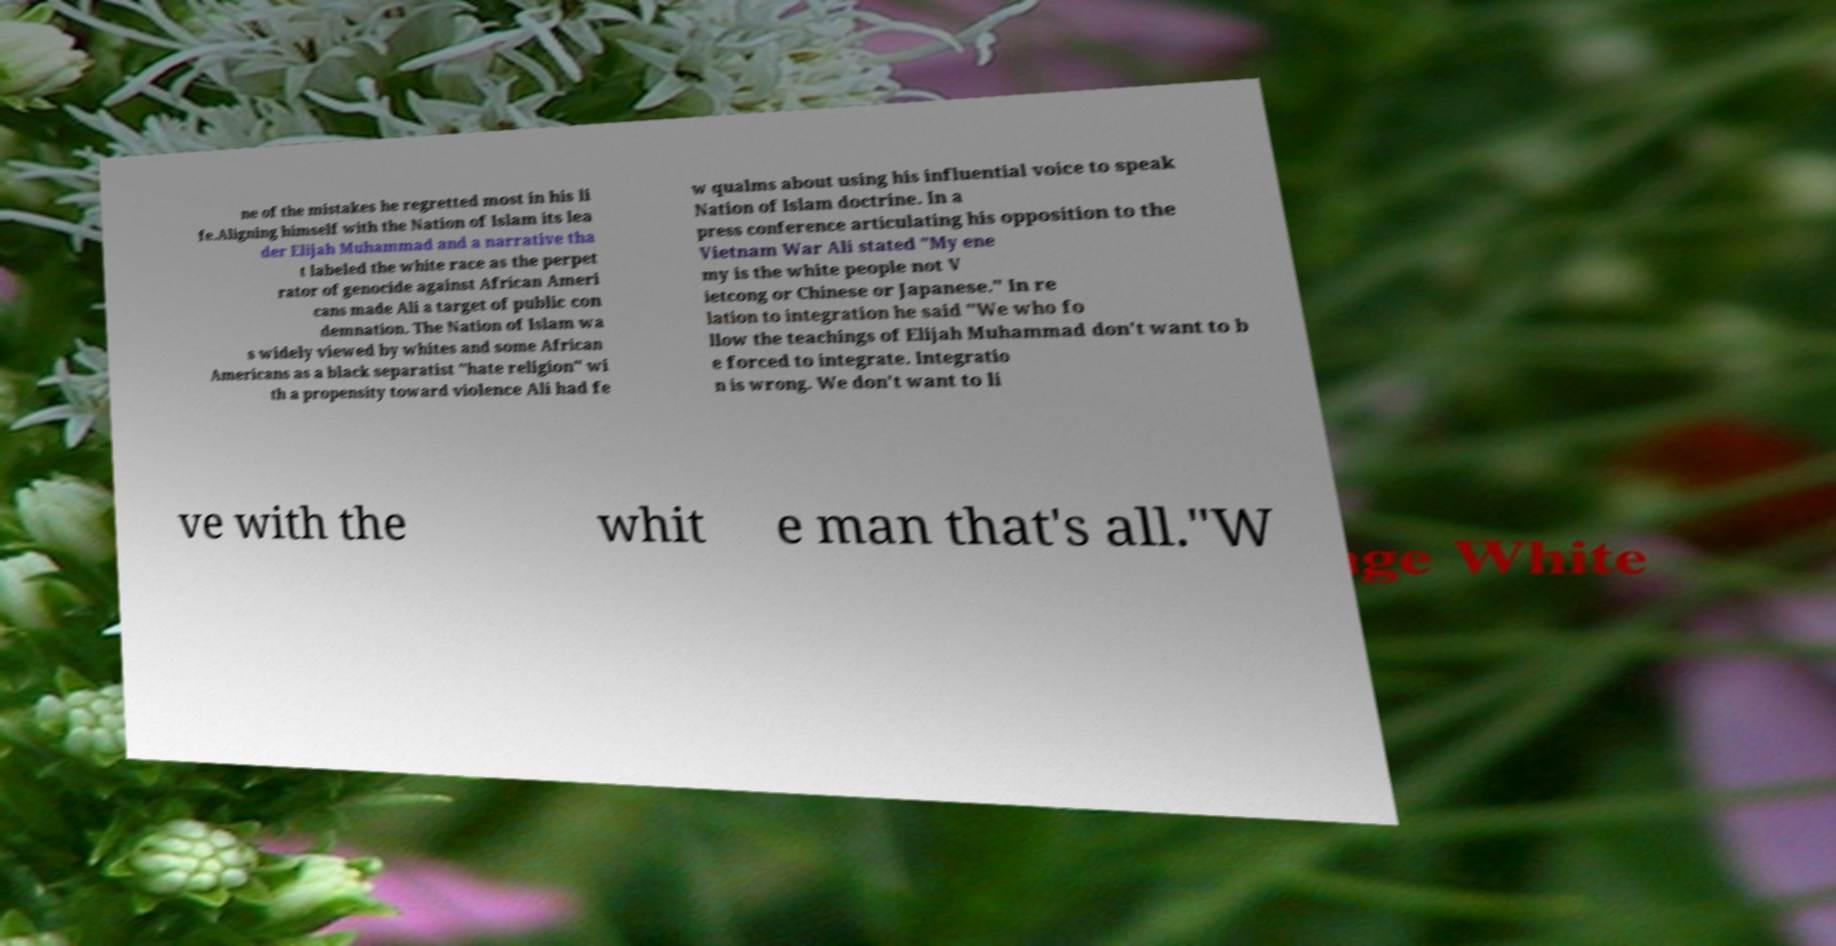Can you accurately transcribe the text from the provided image for me? ne of the mistakes he regretted most in his li fe.Aligning himself with the Nation of Islam its lea der Elijah Muhammad and a narrative tha t labeled the white race as the perpet rator of genocide against African Ameri cans made Ali a target of public con demnation. The Nation of Islam wa s widely viewed by whites and some African Americans as a black separatist "hate religion" wi th a propensity toward violence Ali had fe w qualms about using his influential voice to speak Nation of Islam doctrine. In a press conference articulating his opposition to the Vietnam War Ali stated "My ene my is the white people not V ietcong or Chinese or Japanese." In re lation to integration he said "We who fo llow the teachings of Elijah Muhammad don't want to b e forced to integrate. Integratio n is wrong. We don't want to li ve with the whit e man that's all."W 